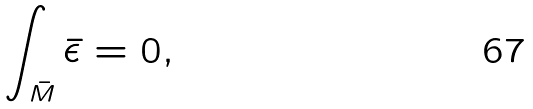Convert formula to latex. <formula><loc_0><loc_0><loc_500><loc_500>\int _ { \bar { M } } \bar { \epsilon } = 0 ,</formula> 